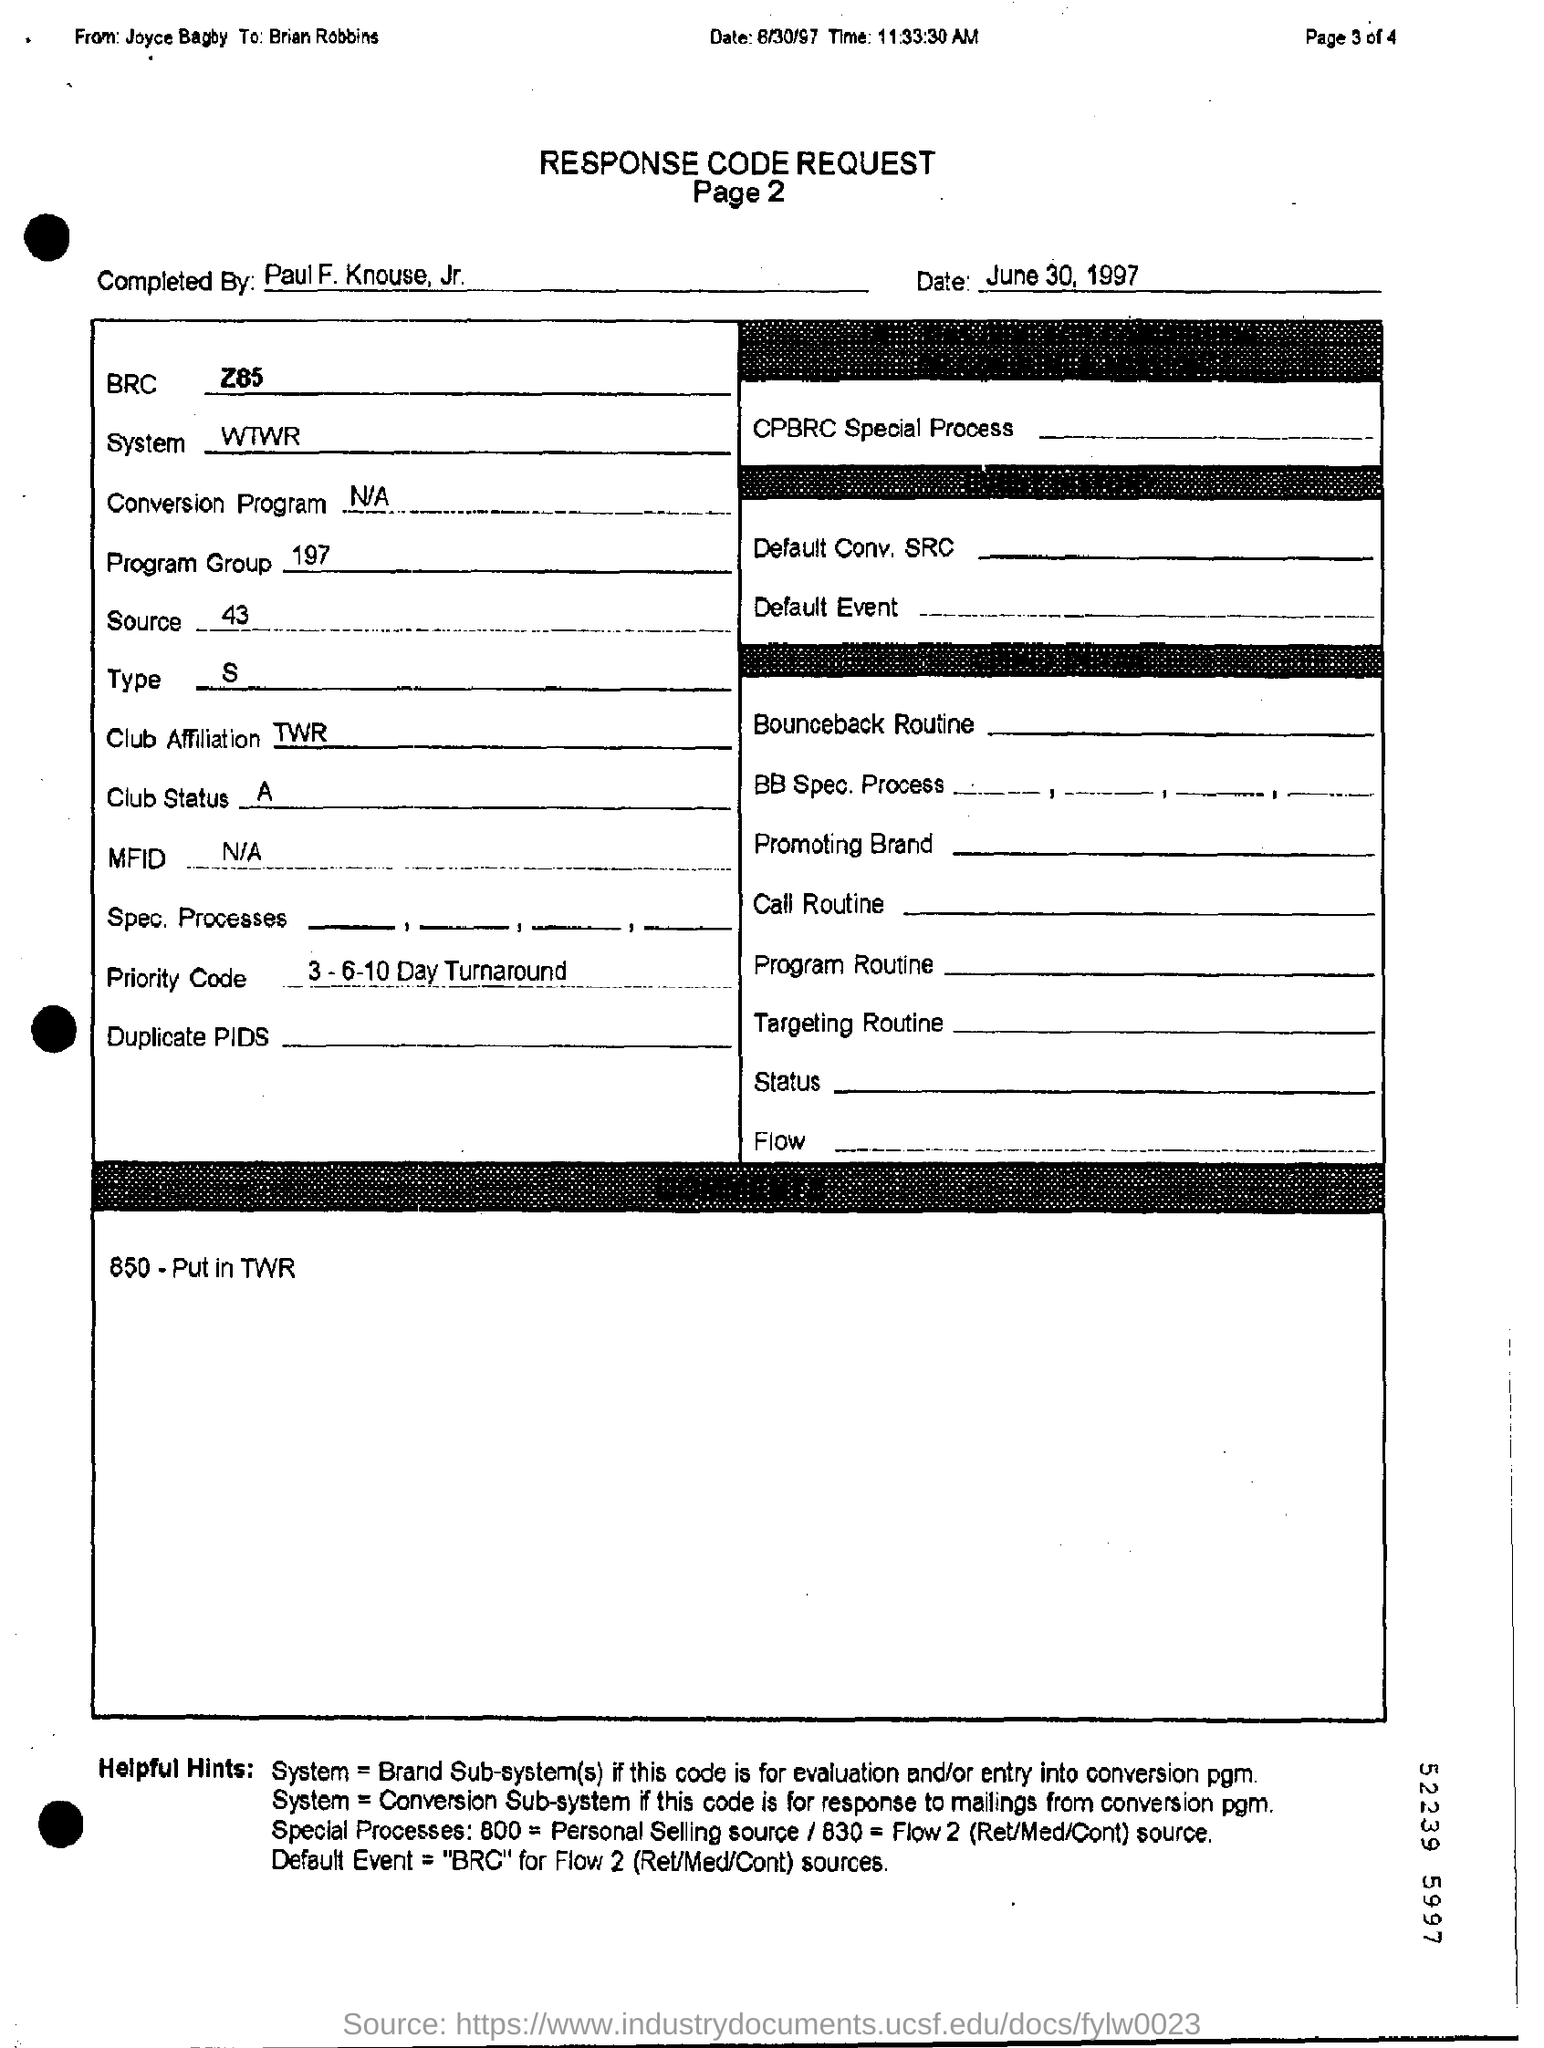Outline some significant characteristics in this image. The program group is a collection of programs that are managed together, typically for organizational or administrative purposes. The date of the request is June 30, 1997. Which program group is mentioned?" is a question asking for information about a particular topic. The number "197" is not sufficient information to answer this question. The sender of the request is unknown, as the message simply reads, 'Who send the request? From Joyce Bagby..' 